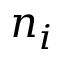<formula> <loc_0><loc_0><loc_500><loc_500>n _ { i }</formula> 